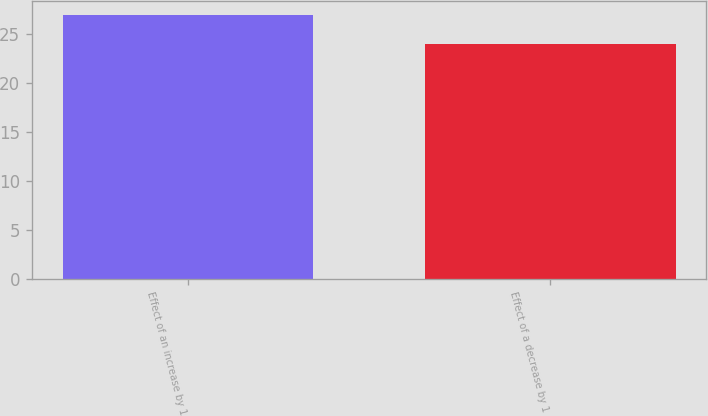Convert chart to OTSL. <chart><loc_0><loc_0><loc_500><loc_500><bar_chart><fcel>Effect of an increase by 1<fcel>Effect of a decrease by 1<nl><fcel>27<fcel>24<nl></chart> 